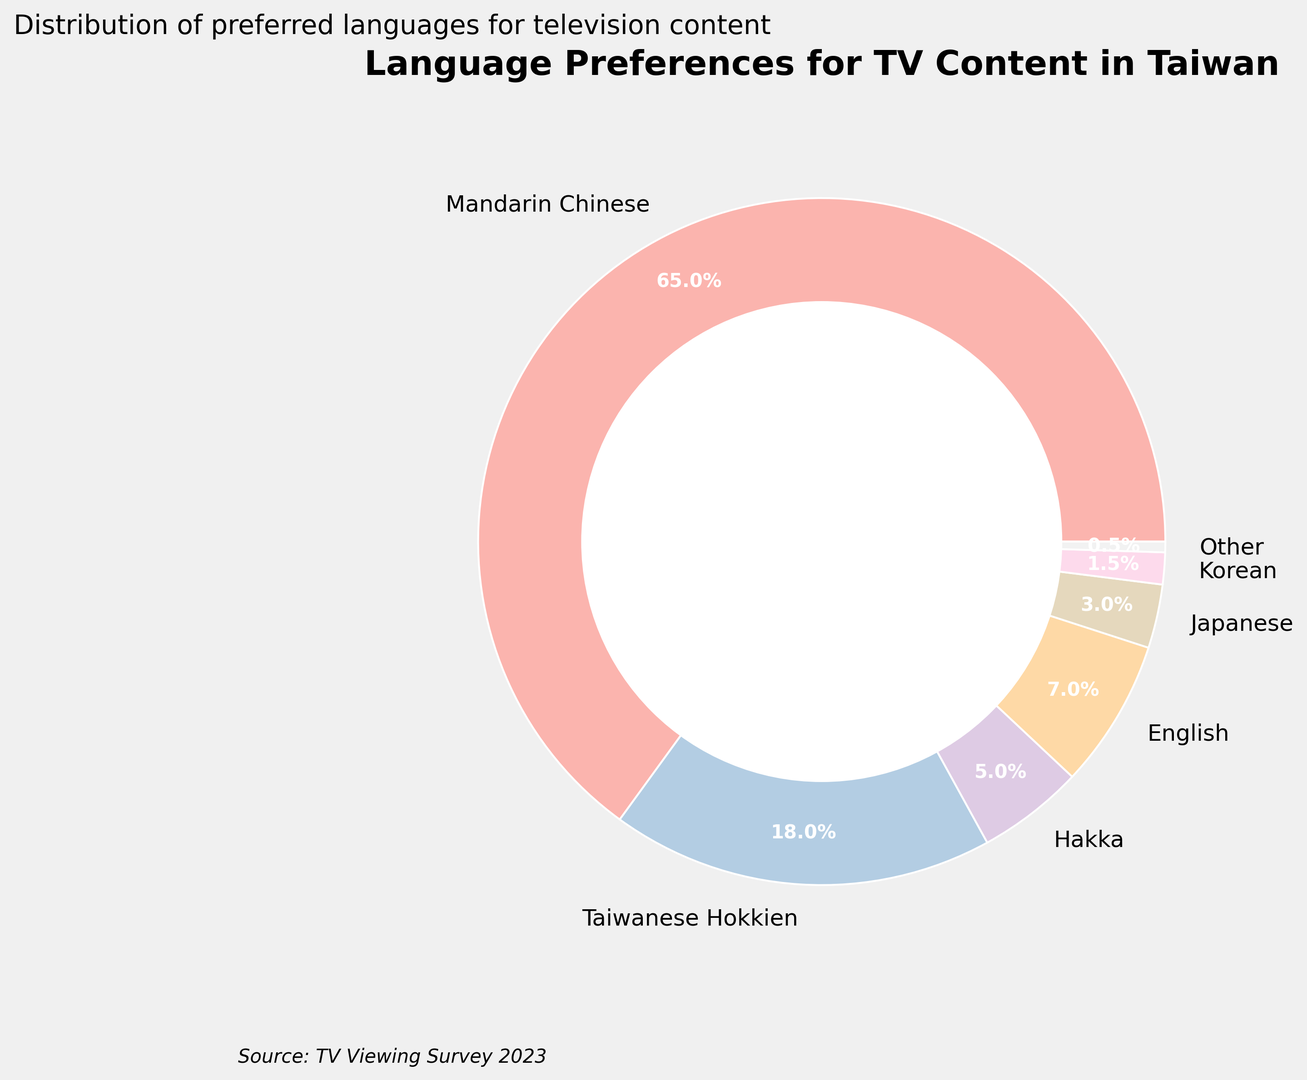How many languages are preferred by at least 5% of the audience? To find the answer, we look at the percentages for each language in the ring chart. Mandarin Chinese (65%), Taiwanese Hokkien (18%), Hakka (5%), English (7%) all fulfill this condition. Thus, 4 languages are preferred by at least 5% of the audience.
Answer: 4 Which language is preferred the least, and what is its percentage? To determine the least preferred language, we identify the smallest percentage in the ring chart. "Other" has the smallest percentage at 0.5%.
Answer: Other, 0.5% What is the combined percentage of viewers who prefer Japanese and Korean content? Add the percentages of Japanese (3%) and Korean (1.5%). The combined percentage is 3% + 1.5% = 4.5%.
Answer: 4.5% What percentage of viewers prefer languages other than Mandarin Chinese and Taiwanese Hokkien? Add the percentages of Hakka (5%), English (7%), Japanese (3%), Korean (1.5%), and Other (0.5%). The total is 5% + 7% + 3% + 1.5% + 0.5% = 17%.
Answer: 17% Compare the preference for Mandarin Chinese and English. How many times more popular is Mandarin Chinese than English? The percentage for Mandarin Chinese is 65%, and for English, it is 7%. To find how many times more popular Mandarin Chinese is, divide 65% by 7%. 65 / 7 ≈ 9.29.
Answer: 9.29 times Which colors correspond to the two most preferred languages in the chart? Looking at the visual elements of the ring chart, Mandarin Chinese and Taiwanese Hokkien are the two most preferred languages. The specific colors are determined by the plot, which typically shows them in distinct colors such as shades from a pastel palette. However, without the exact color palette reference, we broadly say these are the first two colors in the chart palette.
Answer: First two colors What is the difference in preference percentage between Hakka and Japanese content? Subtract the percentage of Japanese (3%) from Hakka (5%). The difference is 5% - 3% = 2%.
Answer: 2% What's the visual layout of the title and subtitle of the chart? The title "Language Preferences for TV Content in Taiwan" is prominently displayed above the chart in a bold font, and the subtitle is below the title, providing additional context about the distribution of preferred languages.
Answer: Title at the top, subtitle below the title What is the combined preference percentage for Korean and Other languages? Add the percentages of Korean (1.5%) and Other (0.5%). The combined percentage is 1.5% + 0.5% = 2%.
Answer: 2% Which language preferences together make up more than 80% of the audience? Mandarin Chinese (65%) and Taiwanese Hokkien (18%) together form the majority. Adding these gives us 65% + 18% = 83%, which is more than 80%. Therefore, the combination of these makes up more than 80%.
Answer: Mandarin Chinese and Taiwanese Hokkien 